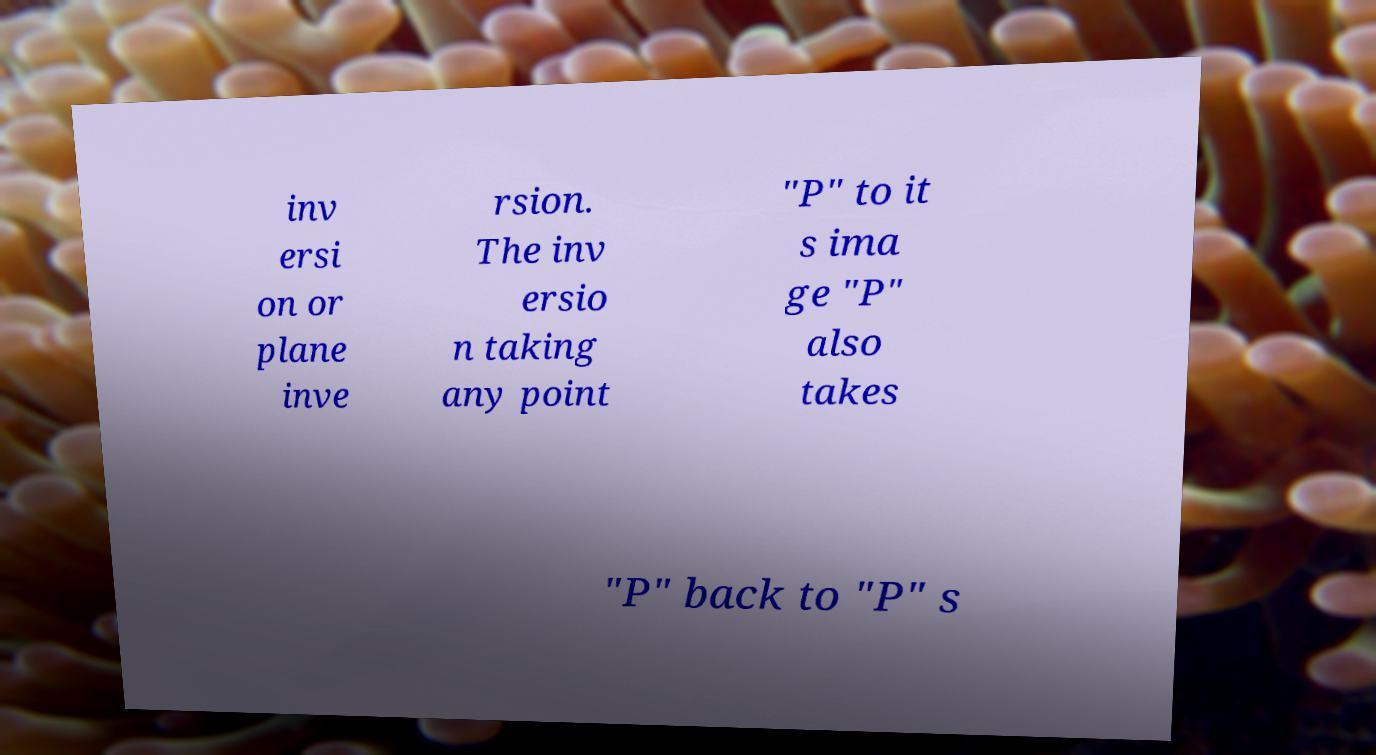Can you read and provide the text displayed in the image?This photo seems to have some interesting text. Can you extract and type it out for me? inv ersi on or plane inve rsion. The inv ersio n taking any point "P" to it s ima ge "P" also takes "P" back to "P" s 